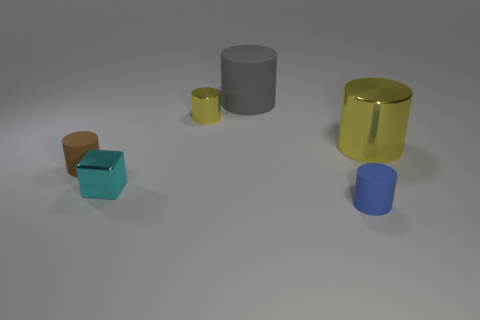Is the number of large gray objects that are left of the gray rubber cylinder less than the number of tiny cubes in front of the large yellow metallic cylinder?
Your answer should be very brief. Yes. What is the material of the thing that is both on the left side of the gray rubber object and behind the small brown object?
Provide a succinct answer. Metal. There is a cyan metallic thing; does it have the same shape as the tiny rubber thing on the right side of the cube?
Your answer should be very brief. No. How many other things are the same size as the blue rubber object?
Provide a short and direct response. 3. Is the number of big gray matte cylinders greater than the number of small cyan cylinders?
Provide a short and direct response. Yes. How many cylinders are to the right of the big matte thing and behind the brown rubber cylinder?
Your response must be concise. 1. The small yellow metallic object left of the gray rubber cylinder that is on the right side of the small metallic thing that is in front of the small brown matte thing is what shape?
Keep it short and to the point. Cylinder. Is there any other thing that has the same shape as the big matte thing?
Give a very brief answer. Yes. What number of blocks are tiny brown things or large shiny objects?
Your answer should be very brief. 0. There is a tiny metallic thing behind the big yellow cylinder; does it have the same color as the big metal object?
Offer a terse response. Yes. 